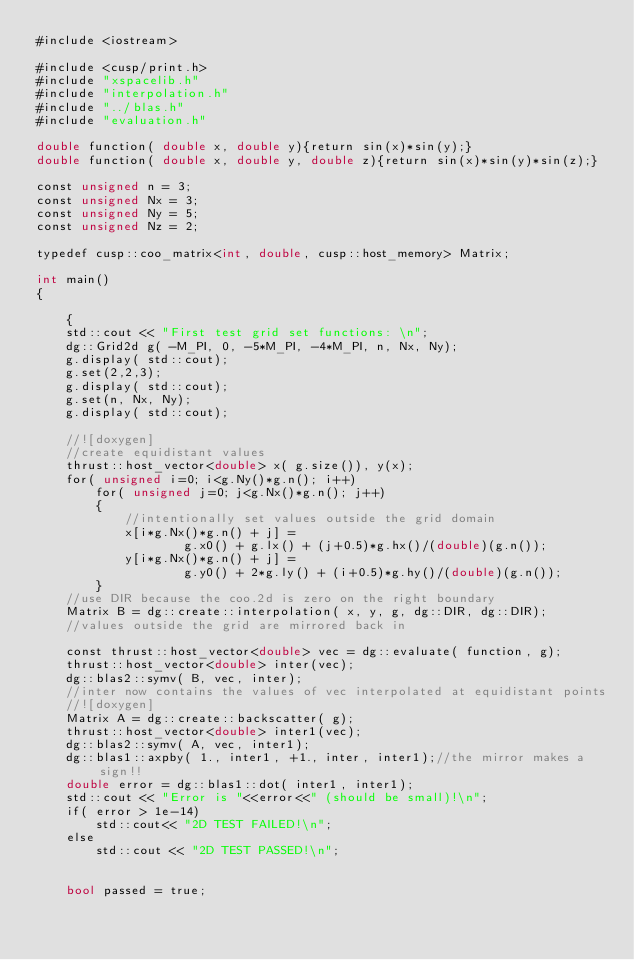Convert code to text. <code><loc_0><loc_0><loc_500><loc_500><_Cuda_>#include <iostream>

#include <cusp/print.h>
#include "xspacelib.h"
#include "interpolation.h"
#include "../blas.h"
#include "evaluation.h"

double function( double x, double y){return sin(x)*sin(y);}
double function( double x, double y, double z){return sin(x)*sin(y)*sin(z);}

const unsigned n = 3;
const unsigned Nx = 3;
const unsigned Ny = 5;
const unsigned Nz = 2;

typedef cusp::coo_matrix<int, double, cusp::host_memory> Matrix;

int main()
{

    {
    std::cout << "First test grid set functions: \n";
    dg::Grid2d g( -M_PI, 0, -5*M_PI, -4*M_PI, n, Nx, Ny);
    g.display( std::cout);
    g.set(2,2,3);
    g.display( std::cout);
    g.set(n, Nx, Ny);
    g.display( std::cout);

    //![doxygen]
    //create equidistant values
    thrust::host_vector<double> x( g.size()), y(x);
    for( unsigned i=0; i<g.Ny()*g.n(); i++)
        for( unsigned j=0; j<g.Nx()*g.n(); j++)
        {
            //intentionally set values outside the grid domain
            x[i*g.Nx()*g.n() + j] =
                    g.x0() + g.lx() + (j+0.5)*g.hx()/(double)(g.n());
            y[i*g.Nx()*g.n() + j] =
                    g.y0() + 2*g.ly() + (i+0.5)*g.hy()/(double)(g.n());
        }
    //use DIR because the coo.2d is zero on the right boundary
    Matrix B = dg::create::interpolation( x, y, g, dg::DIR, dg::DIR);
    //values outside the grid are mirrored back in

    const thrust::host_vector<double> vec = dg::evaluate( function, g);
    thrust::host_vector<double> inter(vec);
    dg::blas2::symv( B, vec, inter);
    //inter now contains the values of vec interpolated at equidistant points
    //![doxygen]
    Matrix A = dg::create::backscatter( g);
    thrust::host_vector<double> inter1(vec);
    dg::blas2::symv( A, vec, inter1);
    dg::blas1::axpby( 1., inter1, +1., inter, inter1);//the mirror makes a sign!!
    double error = dg::blas1::dot( inter1, inter1);
    std::cout << "Error is "<<error<<" (should be small)!\n";
    if( error > 1e-14)
        std::cout<< "2D TEST FAILED!\n";
    else
        std::cout << "2D TEST PASSED!\n";


    bool passed = true;</code> 